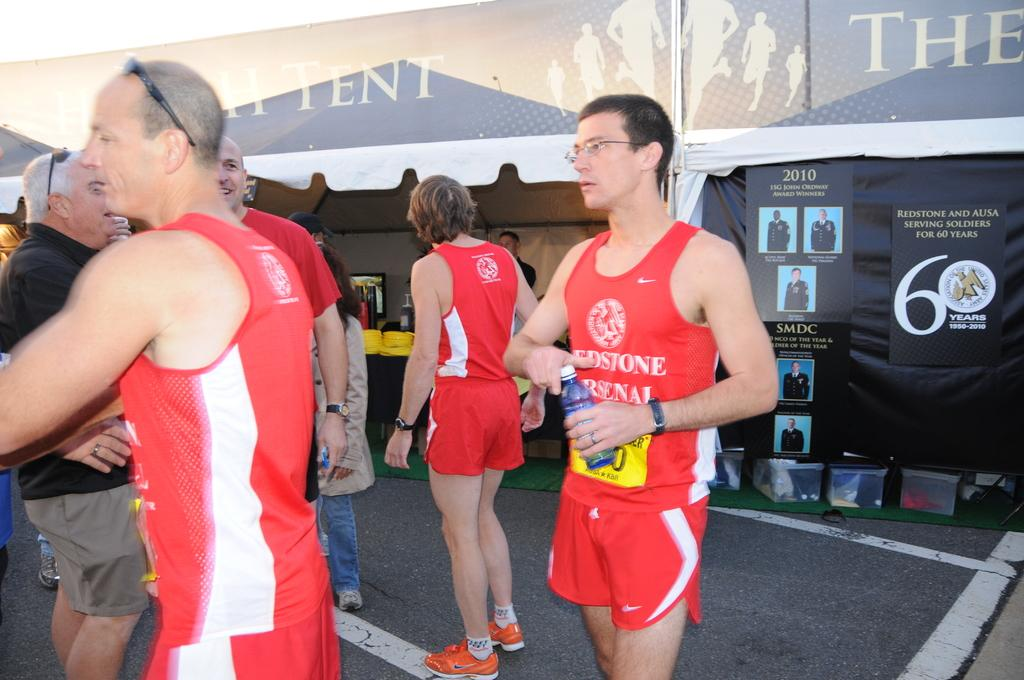<image>
Describe the image concisely. Athletes wearing red are in front of a black wall that has a huge number six on it. 